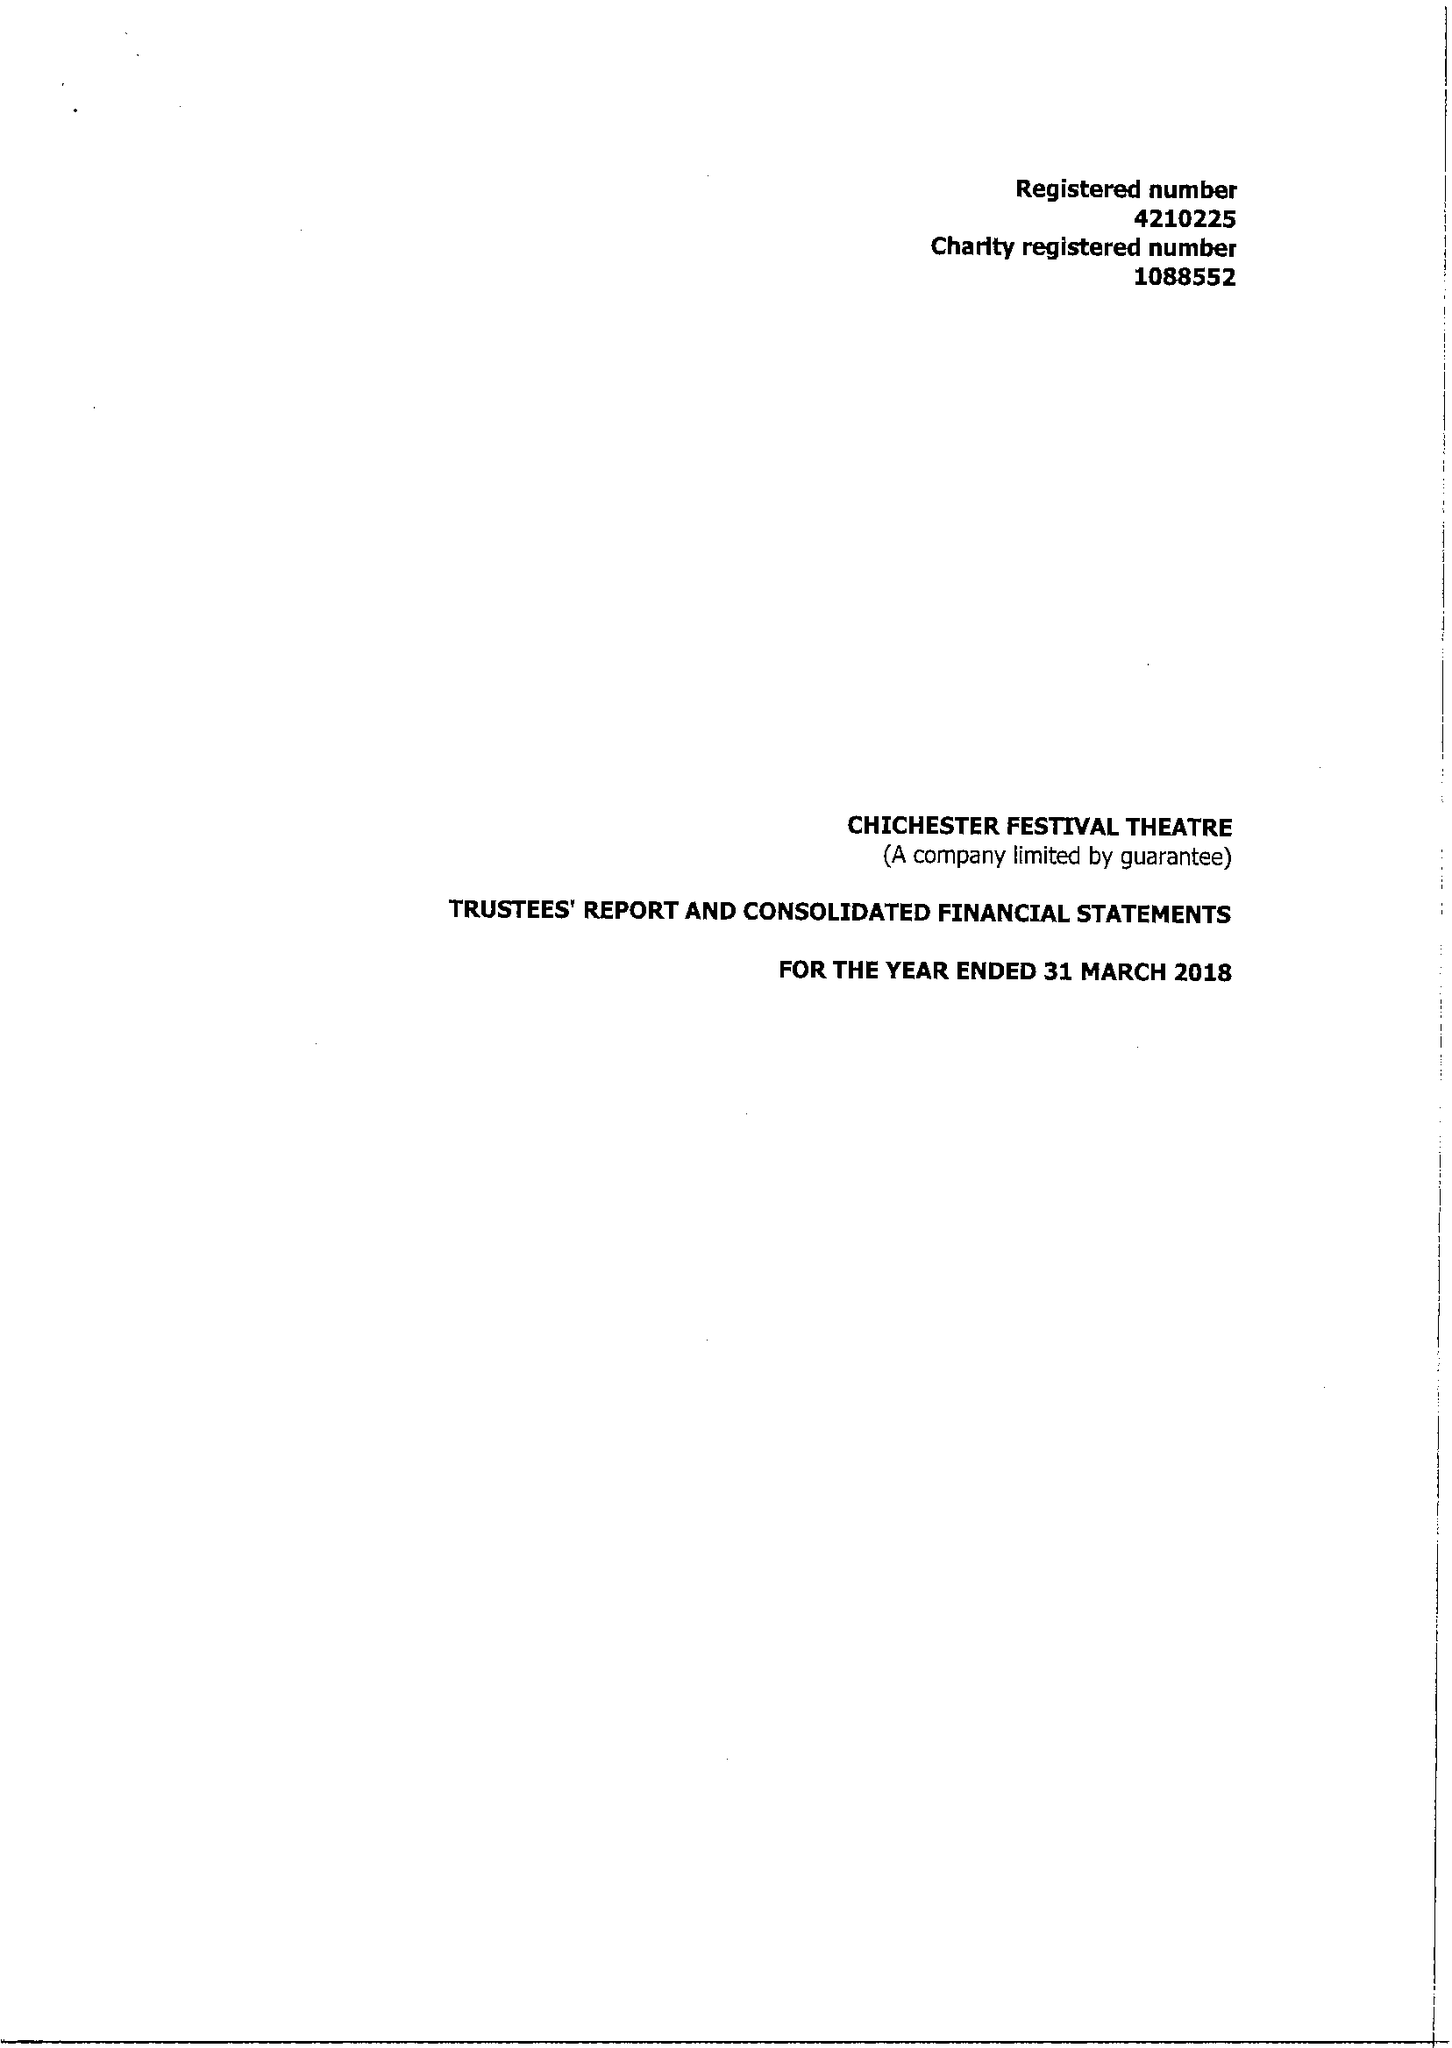What is the value for the charity_name?
Answer the question using a single word or phrase. Chichester Festival Theatre 